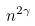<formula> <loc_0><loc_0><loc_500><loc_500>n ^ { 2 \gamma }</formula> 